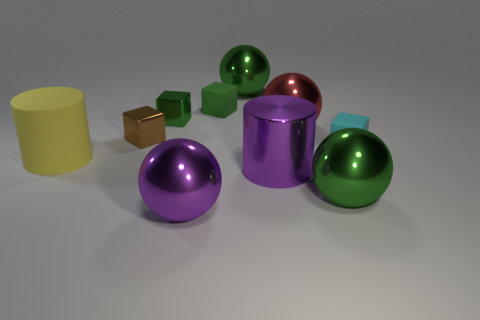Can you infer anything about the lighting in the scene based on the shadows and highlights? The scene seems to be lit by a diffuse overhead light source, as indicated by the soft, broad shadows beneath the objects and the gentle highlights on their surfaces. There are no sharp shadows, suggesting that the light in the scene is not harsh or direct. 